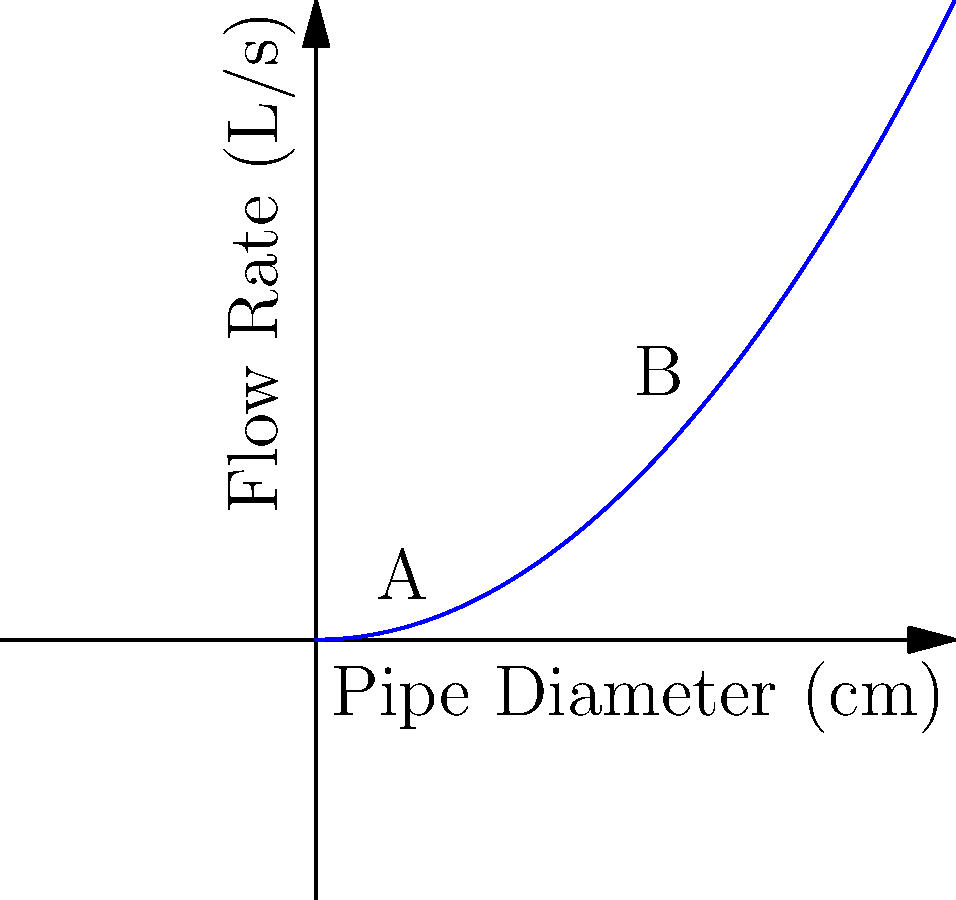In a water treatment plant, two pipes with different diameters are being compared for their flow rates. Given the graph showing the relationship between pipe diameter and flow rate, calculate the percentage increase in flow rate when upgrading from pipe A (2 cm diameter) to pipe B (6 cm diameter). To solve this problem, we'll follow these steps:

1. Determine the flow rates for pipes A and B:
   Pipe A (2 cm diameter): $Q_A = 0.1 * 2^2 = 0.4$ L/s
   Pipe B (6 cm diameter): $Q_B = 0.1 * 6^2 = 3.6$ L/s

2. Calculate the difference in flow rates:
   $\Delta Q = Q_B - Q_A = 3.6 - 0.4 = 3.2$ L/s

3. Calculate the percentage increase:
   Percentage increase = $\frac{\Delta Q}{Q_A} * 100\%$
   $= \frac{3.2}{0.4} * 100\% = 800\%$

The flow rate increases by 800% when upgrading from pipe A to pipe B.

This significant increase is due to the relationship between pipe diameter and flow rate. The flow rate is proportional to the square of the pipe diameter, as shown by the quadratic curve in the graph. This relationship is based on the continuity equation and Bernoulli's principle in fluid dynamics.
Answer: 800% 